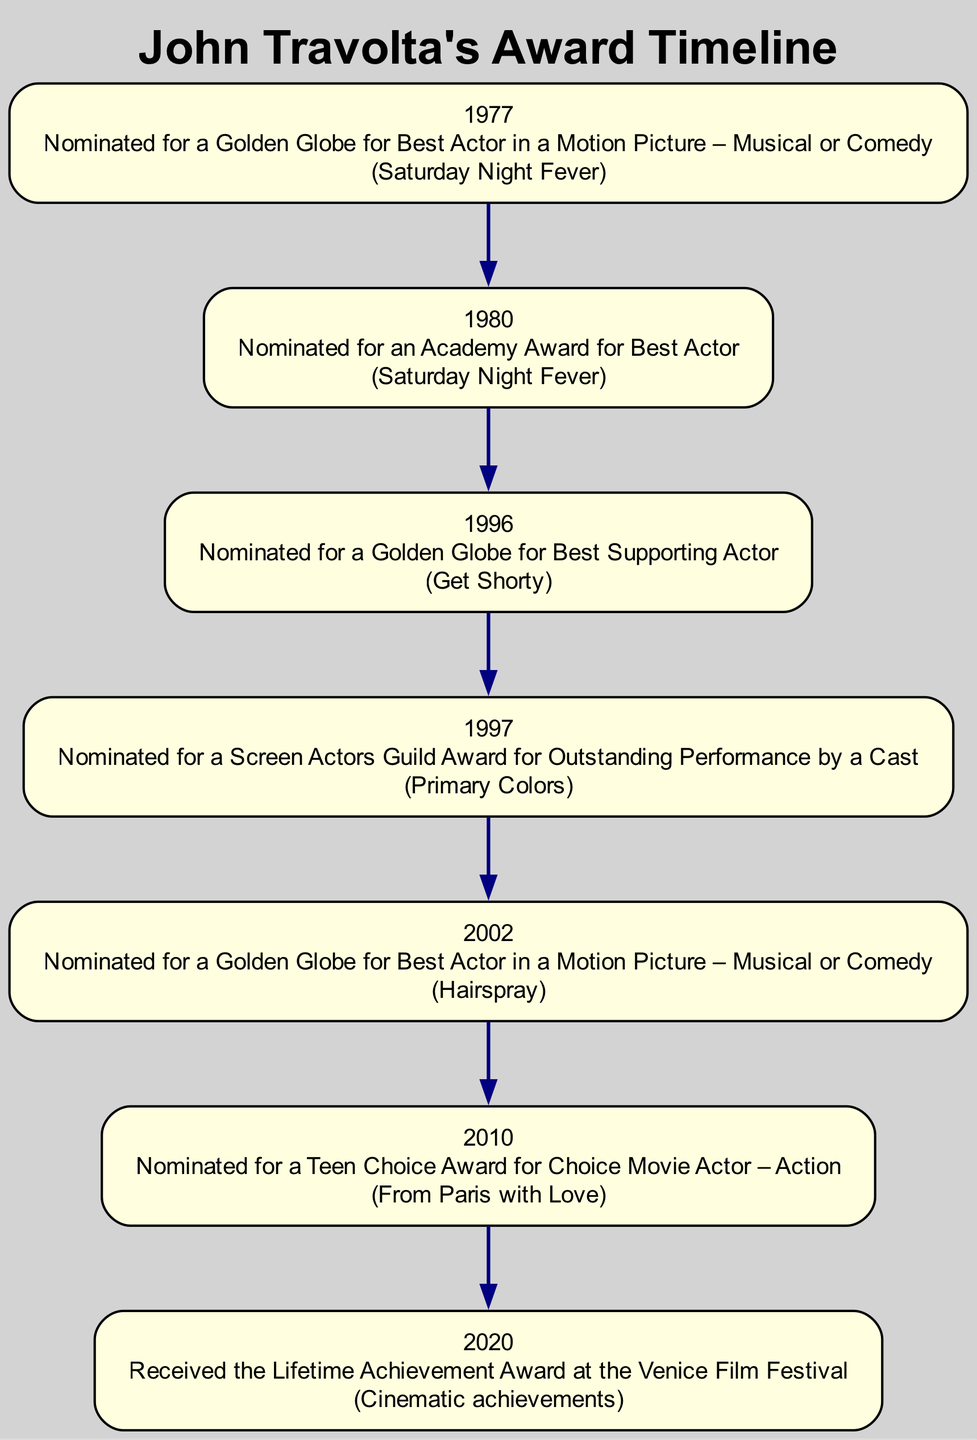What year was John Travolta nominated for an Academy Award for Best Actor? The diagram indicates that John Travolta received an Academy Award nomination in the year 1980 for the film "Saturday Night Fever."
Answer: 1980 What event occurred in 2020? According to the diagram, the event that took place in 2020 was that John Travolta received the Lifetime Achievement Award at the Venice Film Festival for his cinematic achievements.
Answer: Received the Lifetime Achievement Award How many total nominations are shown in the diagram? By counting each event listed in the diagram, there are a total of 6 nominations represented, spanning various awards and years.
Answer: 6 What was the work associated with the nomination for the Golden Globe in 2002? The diagram states that in 2002, John Travolta was nominated for a Golden Globe for Best Actor in a Motion Picture – Musical or Comedy for the film "Hairspray."
Answer: Hairspray Which award was John Travolta nominated for in 1996? In the year 1996, John Travolta was nominated for a Golden Globe for Best Supporting Actor for the film "Get Shorty."
Answer: Golden Globe for Best Supporting Actor Which two awards were he nominated for due to his performance in Saturday Night Fever? The diagram shows that John Travolta was nominated for both a Golden Globe and an Academy Award for his performance in "Saturday Night Fever."
Answer: Golden Globe and Academy Award What is the connection between the events in 1997 and 1996? The events in the years 1996 and 1997 are connected through John Travolta's ongoing recognition in film. In 1996, he was nominated for a Golden Globe, and in 1997, he was nominated for a Screen Actors Guild Award for his role in "Primary Colors," continuing his recognition in the industry.
Answer: Ongoing recognition in film In what year did he receive a lifetime achievement award? The diagram indicates that John Travolta received the Lifetime Achievement Award in the year 2020 at the Venice Film Festival.
Answer: 2020 What type of award was associated with "From Paris with Love" in 2010? In 2010, the diagram indicates that John Travolta was nominated for a Teen Choice Award for his role in "From Paris with Love," which falls under the category of action films.
Answer: Teen Choice Award 